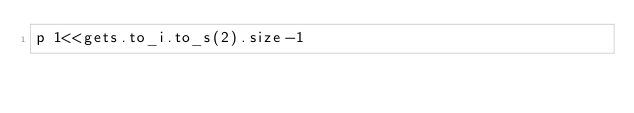<code> <loc_0><loc_0><loc_500><loc_500><_Ruby_>p 1<<gets.to_i.to_s(2).size-1</code> 